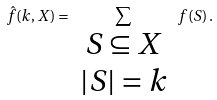Convert formula to latex. <formula><loc_0><loc_0><loc_500><loc_500>\hat { f } ( k , X ) = \sum _ { \begin{array} { c } S \subseteq X \\ | S | = k \end{array} } f ( S ) \, .</formula> 